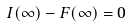Convert formula to latex. <formula><loc_0><loc_0><loc_500><loc_500>I ( \infty ) - F ( \infty ) = 0</formula> 